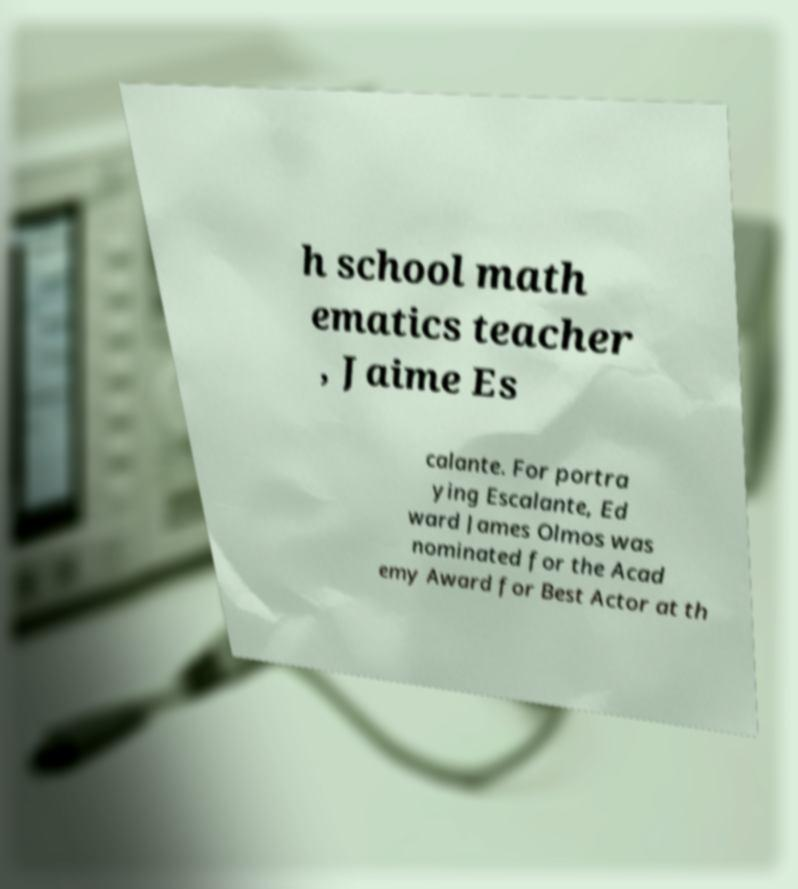For documentation purposes, I need the text within this image transcribed. Could you provide that? h school math ematics teacher , Jaime Es calante. For portra ying Escalante, Ed ward James Olmos was nominated for the Acad emy Award for Best Actor at th 